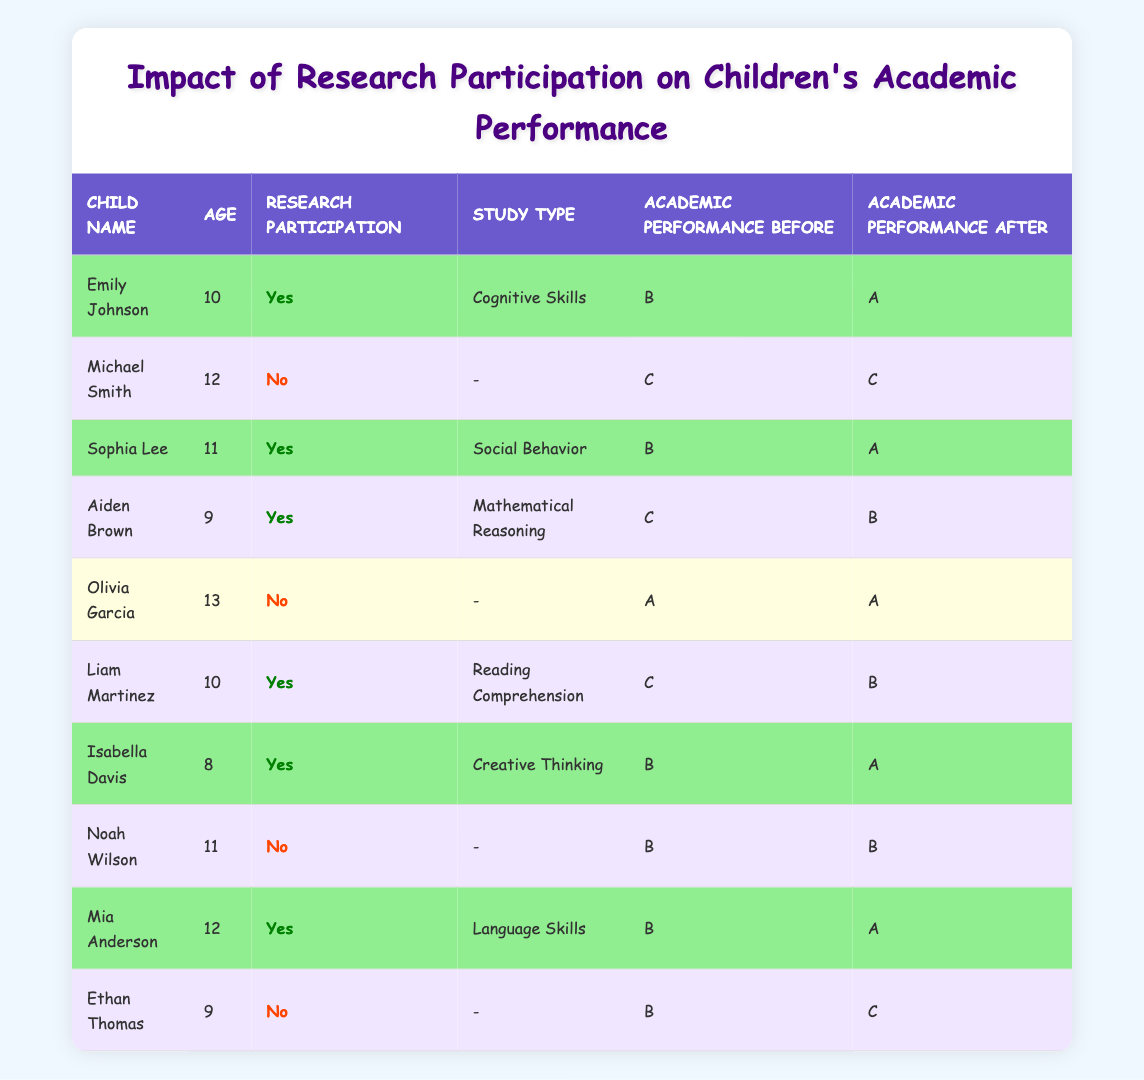What was Emily Johnson's academic performance before participating in the research study? According to the table, Emily Johnson's academic performance before participating in the research study was a "B".
Answer: B How many children participated in the research studies? By counting the rows for children with "Research Participation" marked as "Yes", we find 6 out of the 10 total children participated in research studies.
Answer: 6 What was the academic performance of Liam Martinez after participating in the research study? The table shows that Liam Martinez's academic performance after participating in the research study was "B".
Answer: B Did any child who did not participate in research improve their academic performance? Looking at the table, all children who did not participate (Michael Smith, Olivia Garcia, and Noah Wilson) maintained the same or declined performance, so none improved.
Answer: No What is the average academic performance before participation of all children? To calculate the average, we translate the grades to numerical values (A=4, B=3, C=2). The performances before participation are B, C, B, C, A, B, B. This corresponds to: 3, 2, 3, 2, 4, 3, 3, summing to 20 and dividing by 7 gives an average of about 2.86, which approximates to a B.
Answer: B Which child had the highest improvement in academic performance after research participation? Among those who participated, Emily Johnson improved from B to A, while others also improved, but Emily's change was from B to A representing the highest.
Answer: Emily Johnson Did any of the children who participated in research studies score the same before and after? Reviewing the table, there were no children who participated whose scores remained the same; every child who improved did so with a transition in grade.
Answer: No How many children had the same academic performance before and after? By reviewing the table, the children who had the same performance before and after were Michael Smith, Olivia Garcia, and Noah Wilson, totaling 3 children.
Answer: 3 Among the children who participated in the research studies, how many improved their academic performance? From the data, 5 out of the 6 children who participated improved their academic performance. Only Aiden Brown, Liam Martinez, and Emily Johnson showed improvement.
Answer: 5 What was the academic performance of Mia Anderson before participating in the research study? Mia Anderson's academic performance before participating in the research study, as indicated in the table, was a "B".
Answer: B 